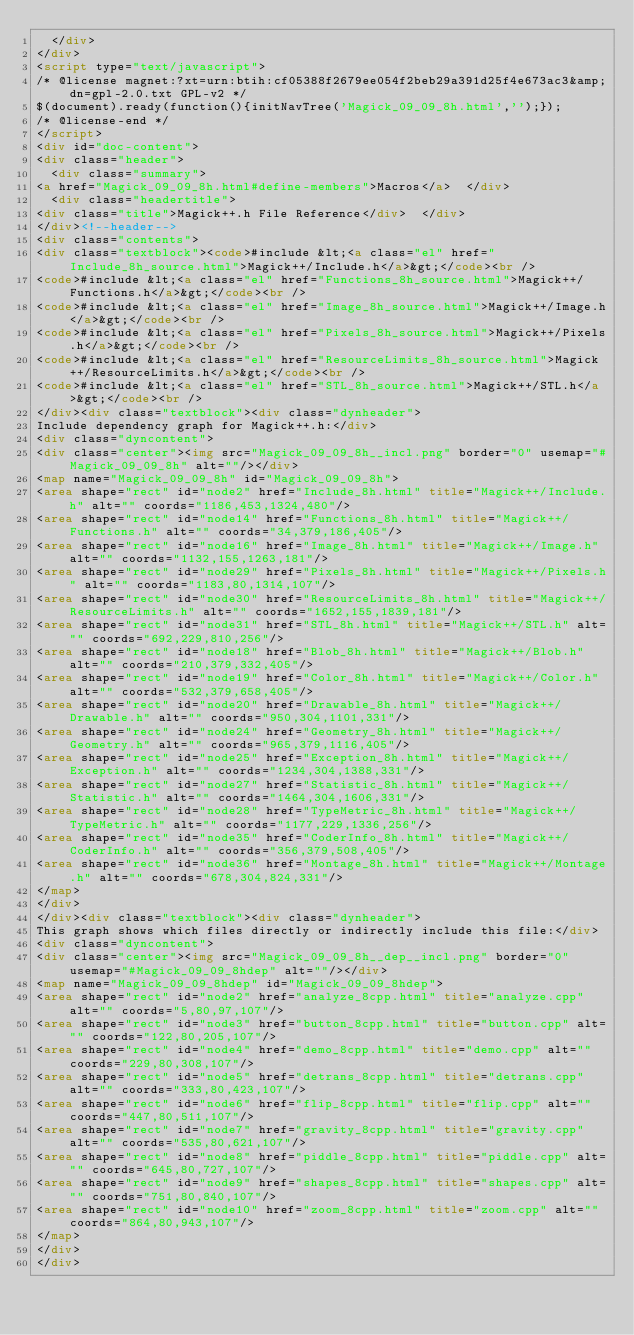<code> <loc_0><loc_0><loc_500><loc_500><_HTML_>  </div>
</div>
<script type="text/javascript">
/* @license magnet:?xt=urn:btih:cf05388f2679ee054f2beb29a391d25f4e673ac3&amp;dn=gpl-2.0.txt GPL-v2 */
$(document).ready(function(){initNavTree('Magick_09_09_8h.html','');});
/* @license-end */
</script>
<div id="doc-content">
<div class="header">
  <div class="summary">
<a href="Magick_09_09_8h.html#define-members">Macros</a>  </div>
  <div class="headertitle">
<div class="title">Magick++.h File Reference</div>  </div>
</div><!--header-->
<div class="contents">
<div class="textblock"><code>#include &lt;<a class="el" href="Include_8h_source.html">Magick++/Include.h</a>&gt;</code><br />
<code>#include &lt;<a class="el" href="Functions_8h_source.html">Magick++/Functions.h</a>&gt;</code><br />
<code>#include &lt;<a class="el" href="Image_8h_source.html">Magick++/Image.h</a>&gt;</code><br />
<code>#include &lt;<a class="el" href="Pixels_8h_source.html">Magick++/Pixels.h</a>&gt;</code><br />
<code>#include &lt;<a class="el" href="ResourceLimits_8h_source.html">Magick++/ResourceLimits.h</a>&gt;</code><br />
<code>#include &lt;<a class="el" href="STL_8h_source.html">Magick++/STL.h</a>&gt;</code><br />
</div><div class="textblock"><div class="dynheader">
Include dependency graph for Magick++.h:</div>
<div class="dyncontent">
<div class="center"><img src="Magick_09_09_8h__incl.png" border="0" usemap="#Magick_09_09_8h" alt=""/></div>
<map name="Magick_09_09_8h" id="Magick_09_09_8h">
<area shape="rect" id="node2" href="Include_8h.html" title="Magick++/Include.h" alt="" coords="1186,453,1324,480"/>
<area shape="rect" id="node14" href="Functions_8h.html" title="Magick++/Functions.h" alt="" coords="34,379,186,405"/>
<area shape="rect" id="node16" href="Image_8h.html" title="Magick++/Image.h" alt="" coords="1132,155,1263,181"/>
<area shape="rect" id="node29" href="Pixels_8h.html" title="Magick++/Pixels.h" alt="" coords="1183,80,1314,107"/>
<area shape="rect" id="node30" href="ResourceLimits_8h.html" title="Magick++/ResourceLimits.h" alt="" coords="1652,155,1839,181"/>
<area shape="rect" id="node31" href="STL_8h.html" title="Magick++/STL.h" alt="" coords="692,229,810,256"/>
<area shape="rect" id="node18" href="Blob_8h.html" title="Magick++/Blob.h" alt="" coords="210,379,332,405"/>
<area shape="rect" id="node19" href="Color_8h.html" title="Magick++/Color.h" alt="" coords="532,379,658,405"/>
<area shape="rect" id="node20" href="Drawable_8h.html" title="Magick++/Drawable.h" alt="" coords="950,304,1101,331"/>
<area shape="rect" id="node24" href="Geometry_8h.html" title="Magick++/Geometry.h" alt="" coords="965,379,1116,405"/>
<area shape="rect" id="node25" href="Exception_8h.html" title="Magick++/Exception.h" alt="" coords="1234,304,1388,331"/>
<area shape="rect" id="node27" href="Statistic_8h.html" title="Magick++/Statistic.h" alt="" coords="1464,304,1606,331"/>
<area shape="rect" id="node28" href="TypeMetric_8h.html" title="Magick++/TypeMetric.h" alt="" coords="1177,229,1336,256"/>
<area shape="rect" id="node35" href="CoderInfo_8h.html" title="Magick++/CoderInfo.h" alt="" coords="356,379,508,405"/>
<area shape="rect" id="node36" href="Montage_8h.html" title="Magick++/Montage.h" alt="" coords="678,304,824,331"/>
</map>
</div>
</div><div class="textblock"><div class="dynheader">
This graph shows which files directly or indirectly include this file:</div>
<div class="dyncontent">
<div class="center"><img src="Magick_09_09_8h__dep__incl.png" border="0" usemap="#Magick_09_09_8hdep" alt=""/></div>
<map name="Magick_09_09_8hdep" id="Magick_09_09_8hdep">
<area shape="rect" id="node2" href="analyze_8cpp.html" title="analyze.cpp" alt="" coords="5,80,97,107"/>
<area shape="rect" id="node3" href="button_8cpp.html" title="button.cpp" alt="" coords="122,80,205,107"/>
<area shape="rect" id="node4" href="demo_8cpp.html" title="demo.cpp" alt="" coords="229,80,308,107"/>
<area shape="rect" id="node5" href="detrans_8cpp.html" title="detrans.cpp" alt="" coords="333,80,423,107"/>
<area shape="rect" id="node6" href="flip_8cpp.html" title="flip.cpp" alt="" coords="447,80,511,107"/>
<area shape="rect" id="node7" href="gravity_8cpp.html" title="gravity.cpp" alt="" coords="535,80,621,107"/>
<area shape="rect" id="node8" href="piddle_8cpp.html" title="piddle.cpp" alt="" coords="645,80,727,107"/>
<area shape="rect" id="node9" href="shapes_8cpp.html" title="shapes.cpp" alt="" coords="751,80,840,107"/>
<area shape="rect" id="node10" href="zoom_8cpp.html" title="zoom.cpp" alt="" coords="864,80,943,107"/>
</map>
</div>
</div></code> 